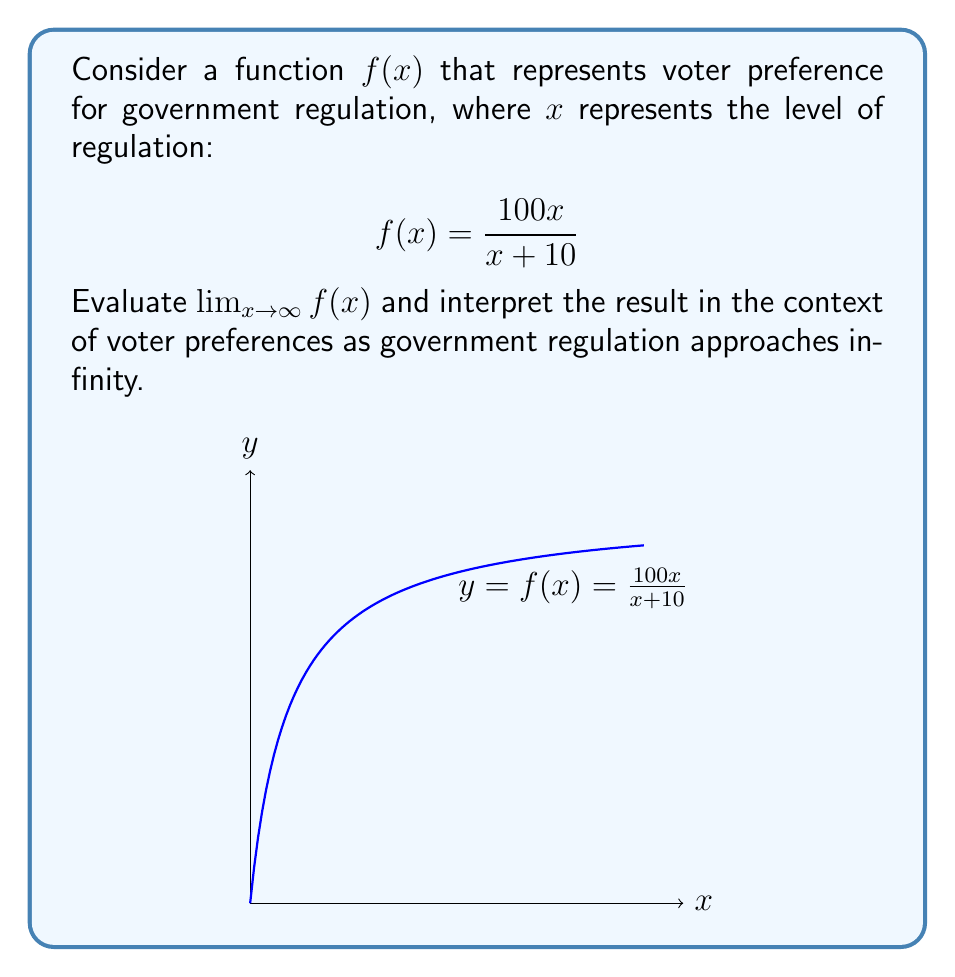Solve this math problem. Let's approach this step-by-step:

1) To evaluate $\lim_{x \to \infty} f(x)$, we need to analyze the behavior of $f(x) = \frac{100x}{x + 10}$ as $x$ approaches infinity.

2) We can rewrite the function as:

   $$f(x) = 100 \cdot \frac{x}{x + 10}$$

3) Dividing both numerator and denominator by $x$:

   $$f(x) = 100 \cdot \frac{1}{1 + \frac{10}{x}}$$

4) As $x$ approaches infinity, $\frac{10}{x}$ approaches 0:

   $$\lim_{x \to \infty} f(x) = 100 \cdot \frac{1}{1 + 0} = 100$$

5) Interpretation: As government regulation ($x$) approaches infinity, voter preference ($f(x)$) approaches 100, which is the maximum value on our scale.

This suggests that in this model, as government regulation increases without bound, voter preference for regulation asymptotically approaches 100%, indicating full support for maximum regulation.
Answer: $\lim_{x \to \infty} f(x) = 100$ 